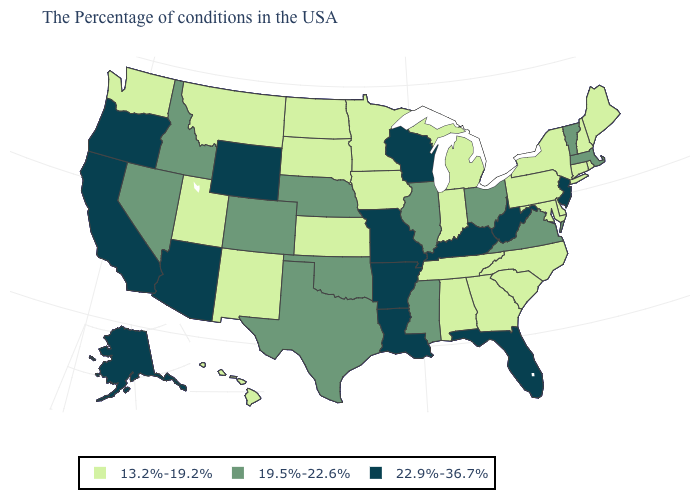Name the states that have a value in the range 22.9%-36.7%?
Give a very brief answer. New Jersey, West Virginia, Florida, Kentucky, Wisconsin, Louisiana, Missouri, Arkansas, Wyoming, Arizona, California, Oregon, Alaska. Is the legend a continuous bar?
Answer briefly. No. Name the states that have a value in the range 13.2%-19.2%?
Answer briefly. Maine, Rhode Island, New Hampshire, Connecticut, New York, Delaware, Maryland, Pennsylvania, North Carolina, South Carolina, Georgia, Michigan, Indiana, Alabama, Tennessee, Minnesota, Iowa, Kansas, South Dakota, North Dakota, New Mexico, Utah, Montana, Washington, Hawaii. Which states have the highest value in the USA?
Give a very brief answer. New Jersey, West Virginia, Florida, Kentucky, Wisconsin, Louisiana, Missouri, Arkansas, Wyoming, Arizona, California, Oregon, Alaska. Name the states that have a value in the range 19.5%-22.6%?
Give a very brief answer. Massachusetts, Vermont, Virginia, Ohio, Illinois, Mississippi, Nebraska, Oklahoma, Texas, Colorado, Idaho, Nevada. Name the states that have a value in the range 19.5%-22.6%?
Short answer required. Massachusetts, Vermont, Virginia, Ohio, Illinois, Mississippi, Nebraska, Oklahoma, Texas, Colorado, Idaho, Nevada. Name the states that have a value in the range 19.5%-22.6%?
Short answer required. Massachusetts, Vermont, Virginia, Ohio, Illinois, Mississippi, Nebraska, Oklahoma, Texas, Colorado, Idaho, Nevada. What is the lowest value in the Northeast?
Keep it brief. 13.2%-19.2%. What is the value of Washington?
Quick response, please. 13.2%-19.2%. What is the value of Hawaii?
Keep it brief. 13.2%-19.2%. Does Montana have the same value as South Carolina?
Keep it brief. Yes. What is the value of Florida?
Answer briefly. 22.9%-36.7%. Does Maine have the lowest value in the Northeast?
Answer briefly. Yes. Name the states that have a value in the range 22.9%-36.7%?
Be succinct. New Jersey, West Virginia, Florida, Kentucky, Wisconsin, Louisiana, Missouri, Arkansas, Wyoming, Arizona, California, Oregon, Alaska. Is the legend a continuous bar?
Answer briefly. No. 